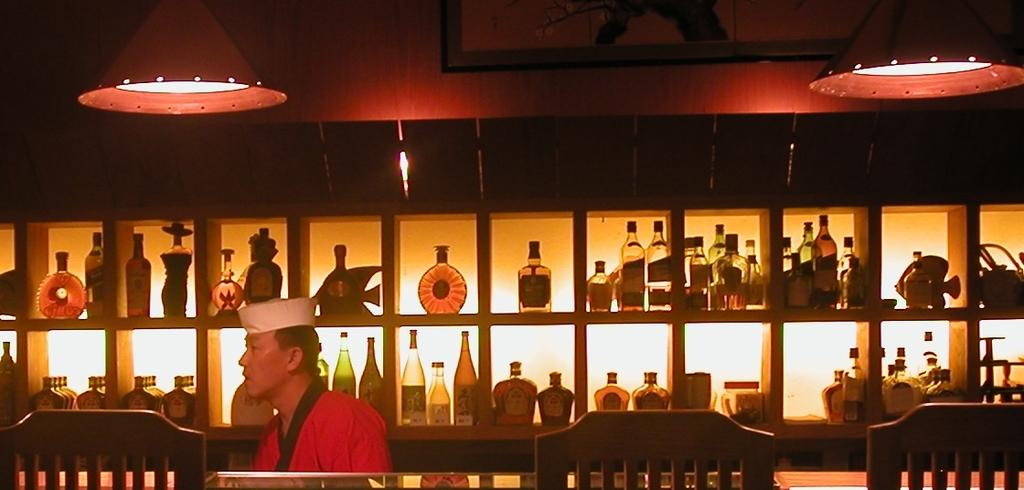What objects can be seen in the image? There are bottles, items on a shelf, and two lamps in the image. Can you describe the person in the image? There is a person with a white hat in the image. How many cattle can be seen in the image? There are no cattle present in the image. What type of lizards are crawling on the person's toe in the image? There are no lizards or toes visible in the image. 